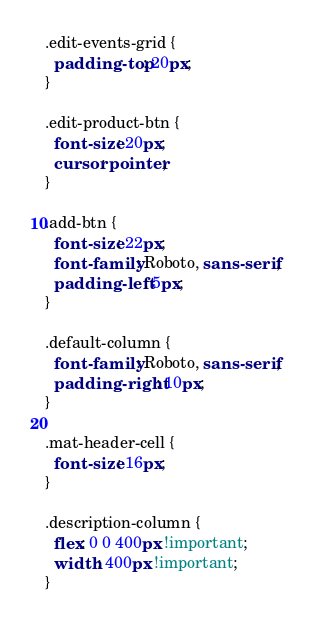Convert code to text. <code><loc_0><loc_0><loc_500><loc_500><_CSS_>.edit-events-grid {
  padding-top: 20px;
}

.edit-product-btn {
  font-size: 20px;
  cursor: pointer;
}

.add-btn {
  font-size: 22px;
  font-family: Roboto, sans-serif;
  padding-left: 5px;
}

.default-column {
  font-family: Roboto, sans-serif;
  padding-right: 10px;
}

.mat-header-cell {
  font-size: 16px;
}

.description-column {
  flex: 0 0 400px !important;
  width: 400px !important;
}
</code> 